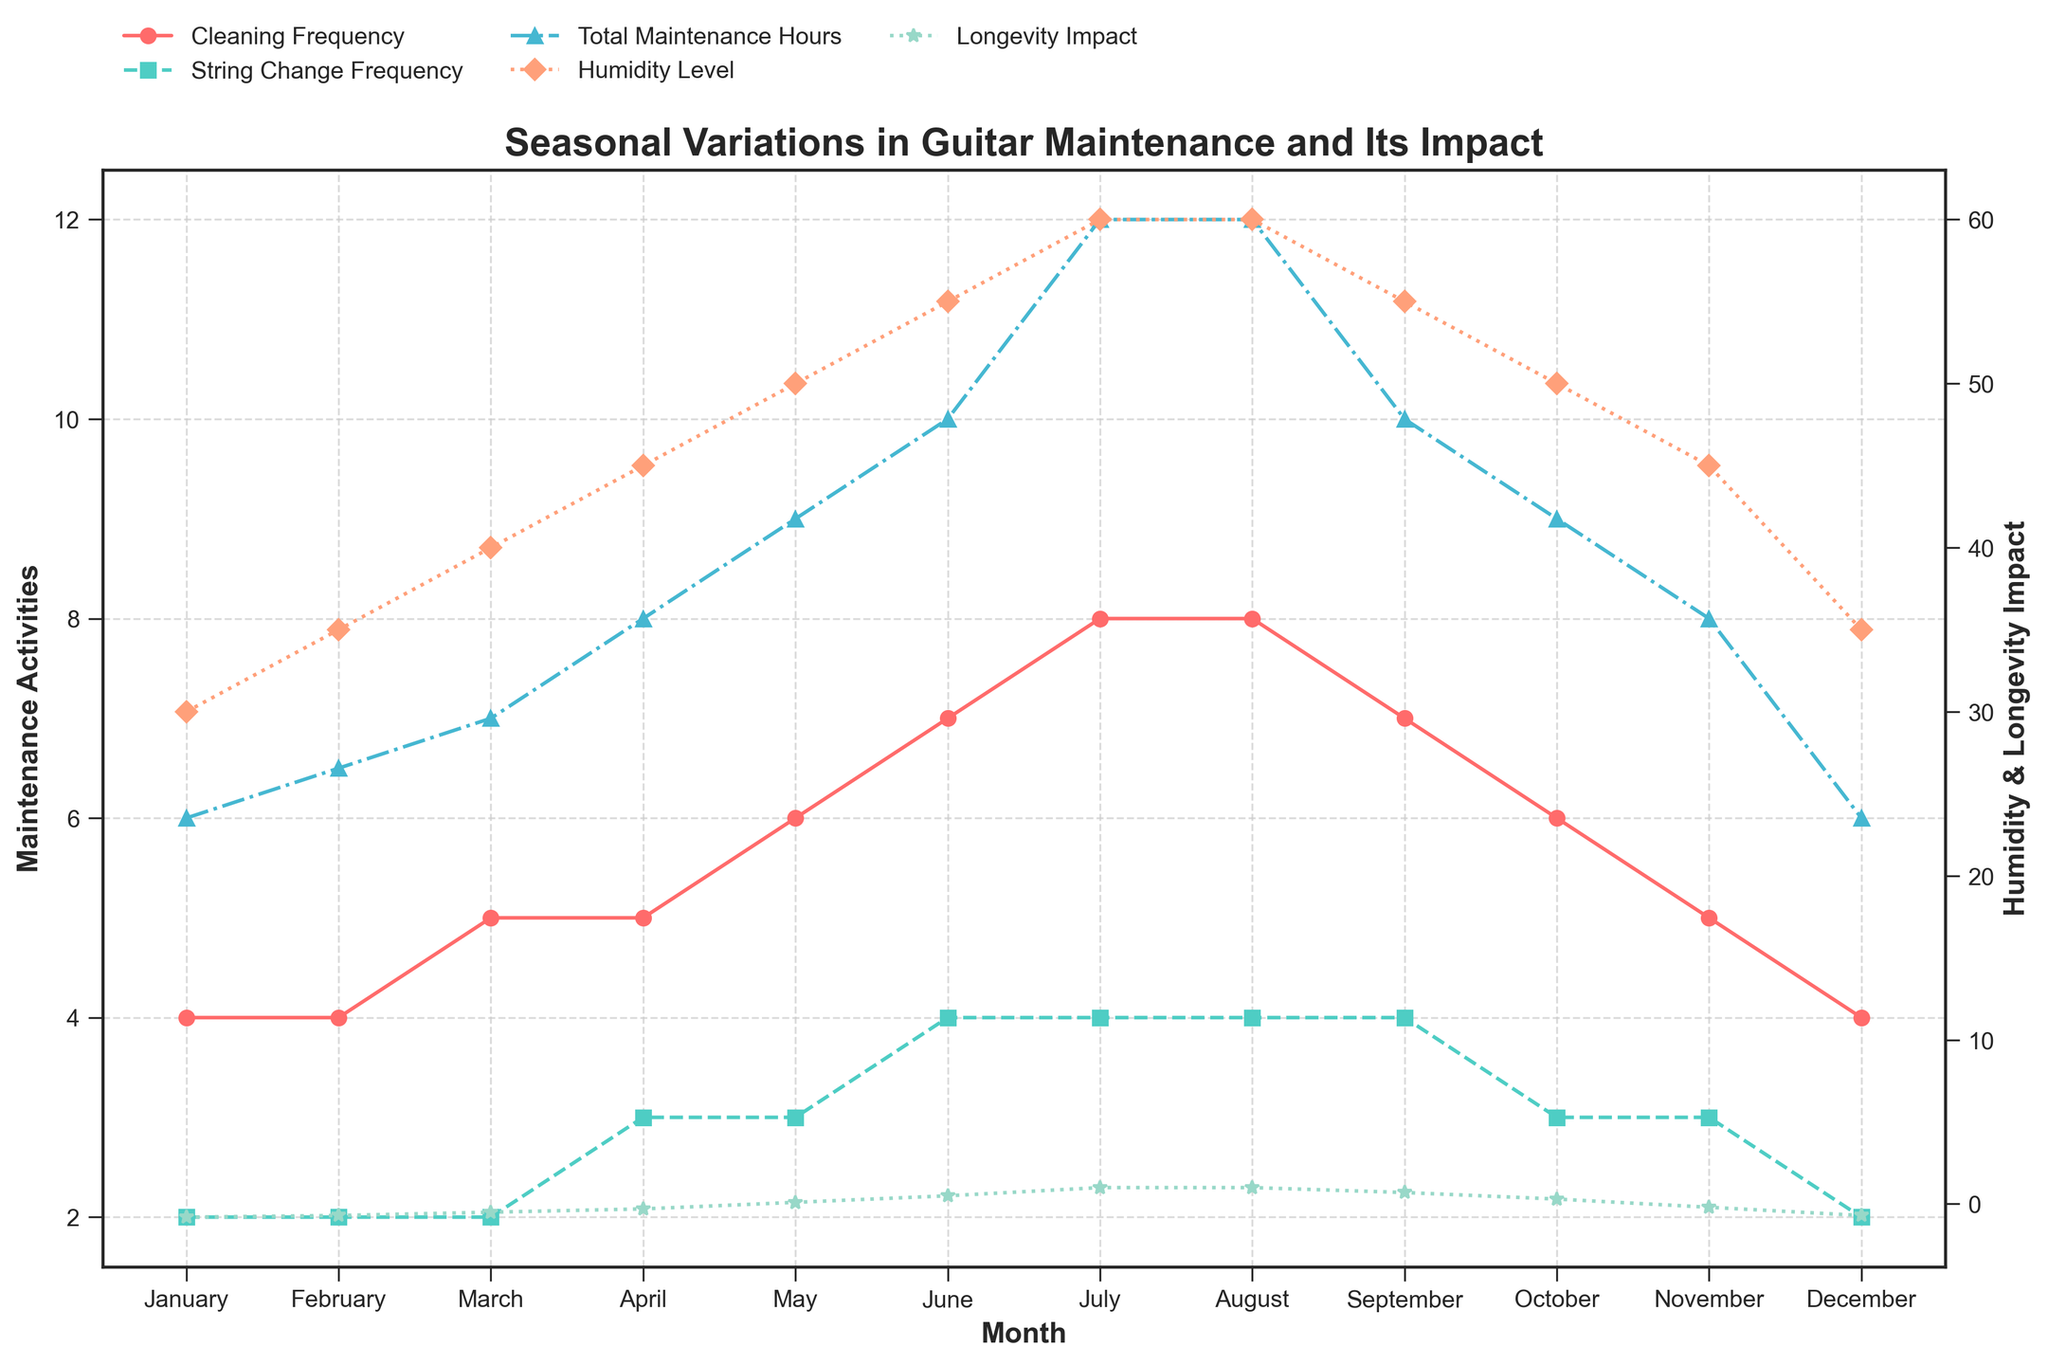What is the title of the figure? The title of the figure is located at the top and usually summarizes the overall content of the figure. By reading it, we can understand the main subject being depicted.
Answer: Seasonal Variations in Guitar Maintenance and Its Impact What is the humidity level in July? To find the humidity level in July, look for the 'Humidity Level' line (marked with diamonds) on the secondary y-axis and find the value corresponding to July.
Answer: 60% Which month has the highest Cleaning Frequency? By observing the 'Cleaning Frequency' line (marked with circles) on the primary y-axis and comparing the values month-by-month, we see that the highest point is in July and August.
Answer: July and August How does the Instrument Longevity Impact change from January to June? Identify the 'Instrument Longevity Impact' line (marked with stars) on the secondary y-axis. Note the values in January (-0.8%) and June (0.5%) and calculate the change.
Answer: It increases by 1.3% What is the average Total Maintenance Hours per month? Sum the values for Total Maintenance Hours over all months (6+6.5+7+8+9+10+12+12+10+9+8+6=93.5), then divide by the number of months (12).
Answer: 7.79 hours/month Do higher humidity levels correlate with increased Longevity Impact? Compare the humidity levels and longevity impact values over the months. High humidity months (July and August) have a positive longevity impact, suggesting a correlation.
Answer: Yes, they correlate Which month shows the maximum Total Maintenance Hours, and what is that value? Locate the 'Total Maintenance Hours' line (marked with triangles) on the primary y-axis and find the peak value which occurs in July and August.
Answer: July and August, 12 hours Is there a month where both Humidity Level and Instrument Longevity Impact peak together? Observe both the 'Humidity Level' and 'Longevity Impact' lines; July and August have peak values for both.
Answer: Yes, July and August What is the difference in Cleaning Frequency between April and October? Find the Cleaning Frequency values for April (5) and October (6), then subtract April's value from October's value.
Answer: 1 time/month How do Cleaning Frequency and String Change Frequency compare in May? Note the values for Cleaning Frequency (6) and String Change Frequency (3) in May, and observe that Cleaning Frequency is twice String Change Frequency.
Answer: Cleaning Frequency is higher 